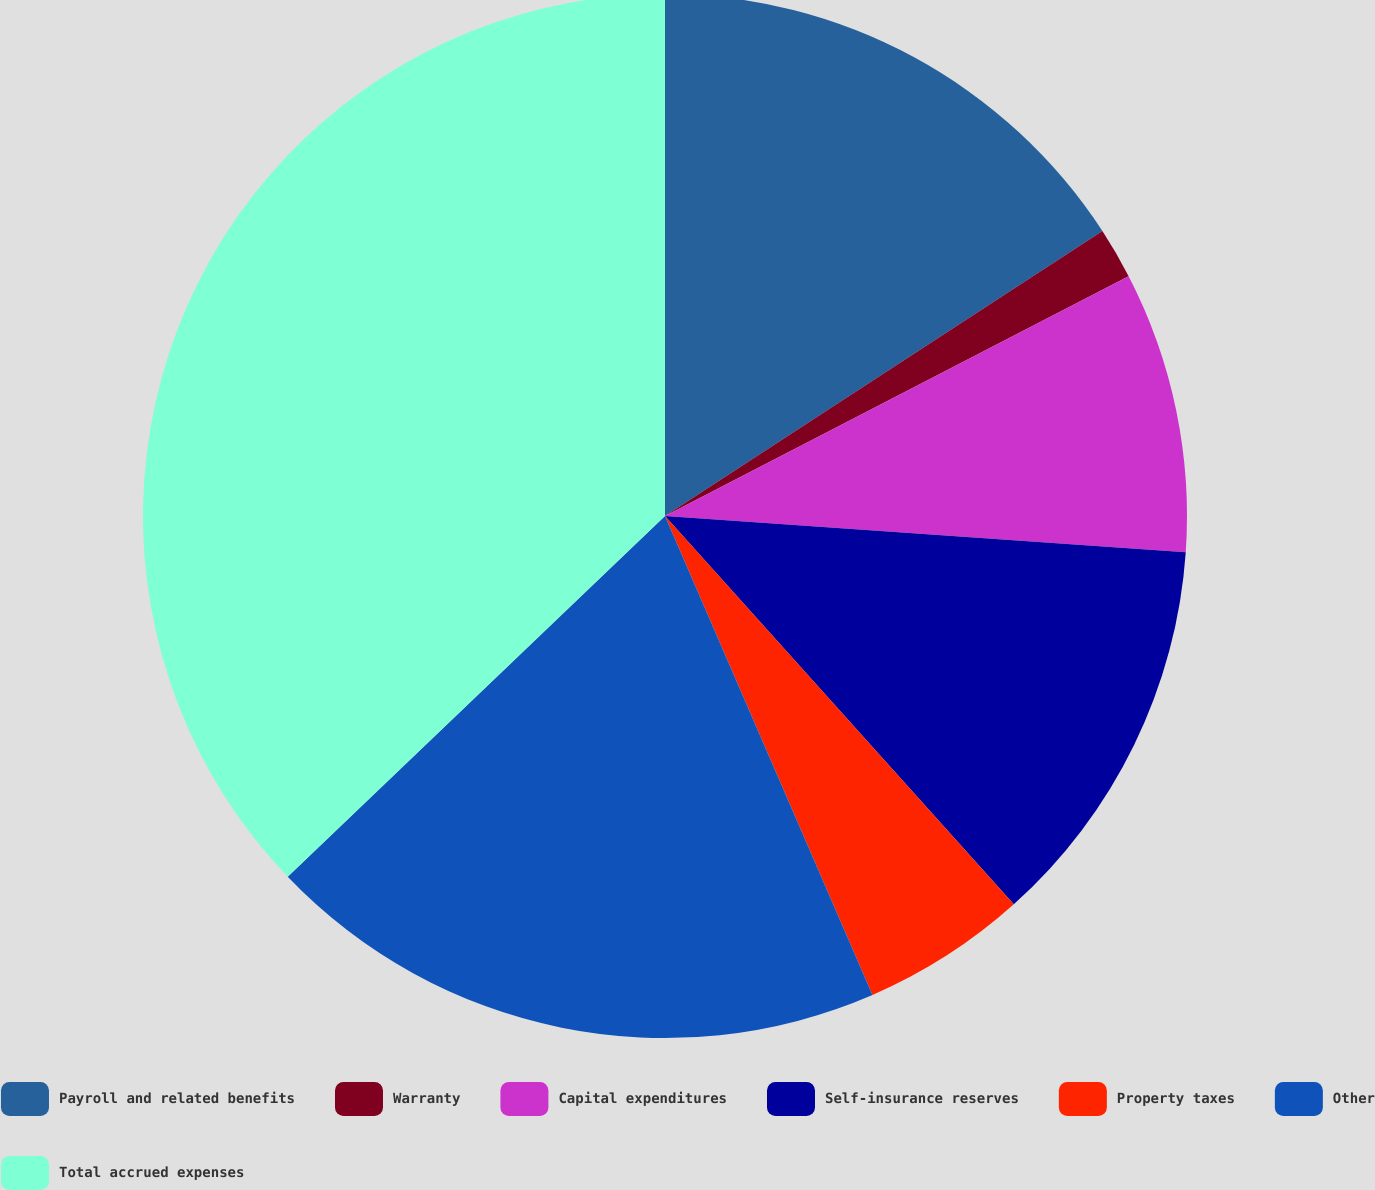Convert chart. <chart><loc_0><loc_0><loc_500><loc_500><pie_chart><fcel>Payroll and related benefits<fcel>Warranty<fcel>Capital expenditures<fcel>Self-insurance reserves<fcel>Property taxes<fcel>Other<fcel>Total accrued expenses<nl><fcel>15.81%<fcel>1.59%<fcel>8.7%<fcel>12.25%<fcel>5.14%<fcel>19.36%<fcel>37.14%<nl></chart> 